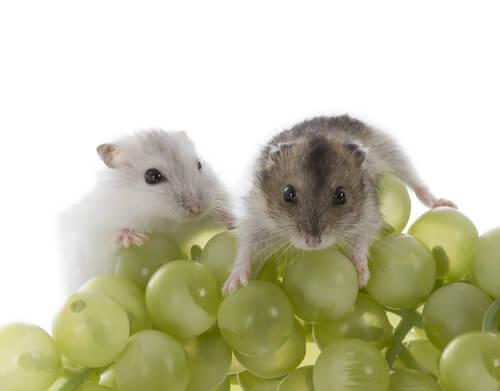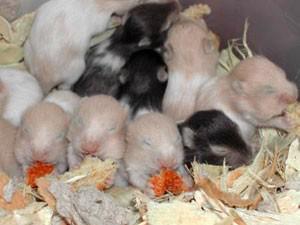The first image is the image on the left, the second image is the image on the right. Assess this claim about the two images: "The food in the left image is green in color.". Correct or not? Answer yes or no. Yes. The first image is the image on the left, the second image is the image on the right. Analyze the images presented: Is the assertion "There are two hamsters who are eating food." valid? Answer yes or no. No. 